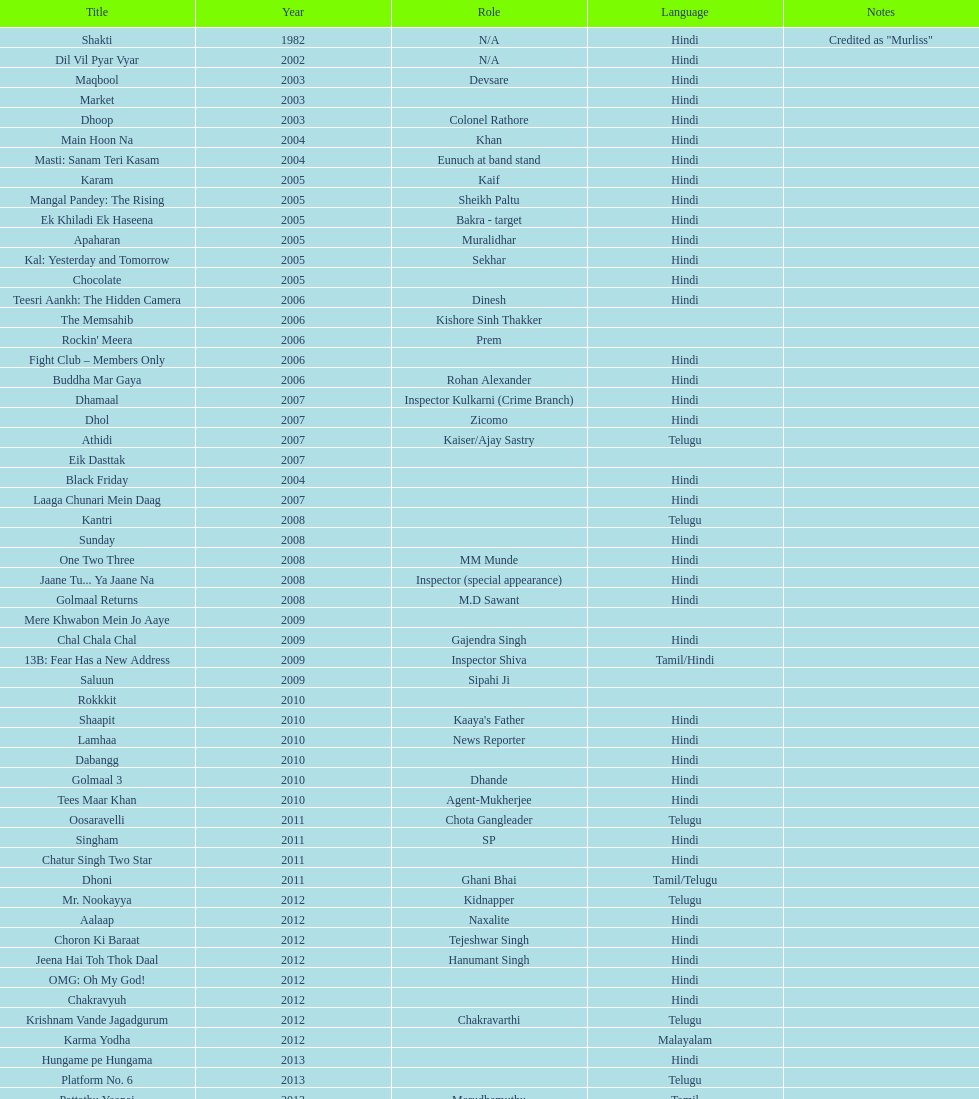Could you parse the entire table? {'header': ['Title', 'Year', 'Role', 'Language', 'Notes'], 'rows': [['Shakti', '1982', 'N/A', 'Hindi', 'Credited as "Murliss"'], ['Dil Vil Pyar Vyar', '2002', 'N/A', 'Hindi', ''], ['Maqbool', '2003', 'Devsare', 'Hindi', ''], ['Market', '2003', '', 'Hindi', ''], ['Dhoop', '2003', 'Colonel Rathore', 'Hindi', ''], ['Main Hoon Na', '2004', 'Khan', 'Hindi', ''], ['Masti: Sanam Teri Kasam', '2004', 'Eunuch at band stand', 'Hindi', ''], ['Karam', '2005', 'Kaif', 'Hindi', ''], ['Mangal Pandey: The Rising', '2005', 'Sheikh Paltu', 'Hindi', ''], ['Ek Khiladi Ek Haseena', '2005', 'Bakra - target', 'Hindi', ''], ['Apaharan', '2005', 'Muralidhar', 'Hindi', ''], ['Kal: Yesterday and Tomorrow', '2005', 'Sekhar', 'Hindi', ''], ['Chocolate', '2005', '', 'Hindi', ''], ['Teesri Aankh: The Hidden Camera', '2006', 'Dinesh', 'Hindi', ''], ['The Memsahib', '2006', 'Kishore Sinh Thakker', '', ''], ["Rockin' Meera", '2006', 'Prem', '', ''], ['Fight Club – Members Only', '2006', '', 'Hindi', ''], ['Buddha Mar Gaya', '2006', 'Rohan Alexander', 'Hindi', ''], ['Dhamaal', '2007', 'Inspector Kulkarni (Crime Branch)', 'Hindi', ''], ['Dhol', '2007', 'Zicomo', 'Hindi', ''], ['Athidi', '2007', 'Kaiser/Ajay Sastry', 'Telugu', ''], ['Eik Dasttak', '2007', '', '', ''], ['Black Friday', '2004', '', 'Hindi', ''], ['Laaga Chunari Mein Daag', '2007', '', 'Hindi', ''], ['Kantri', '2008', '', 'Telugu', ''], ['Sunday', '2008', '', 'Hindi', ''], ['One Two Three', '2008', 'MM Munde', 'Hindi', ''], ['Jaane Tu... Ya Jaane Na', '2008', 'Inspector (special appearance)', 'Hindi', ''], ['Golmaal Returns', '2008', 'M.D Sawant', 'Hindi', ''], ['Mere Khwabon Mein Jo Aaye', '2009', '', '', ''], ['Chal Chala Chal', '2009', 'Gajendra Singh', 'Hindi', ''], ['13B: Fear Has a New Address', '2009', 'Inspector Shiva', 'Tamil/Hindi', ''], ['Saluun', '2009', 'Sipahi Ji', '', ''], ['Rokkkit', '2010', '', '', ''], ['Shaapit', '2010', "Kaaya's Father", 'Hindi', ''], ['Lamhaa', '2010', 'News Reporter', 'Hindi', ''], ['Dabangg', '2010', '', 'Hindi', ''], ['Golmaal 3', '2010', 'Dhande', 'Hindi', ''], ['Tees Maar Khan', '2010', 'Agent-Mukherjee', 'Hindi', ''], ['Oosaravelli', '2011', 'Chota Gangleader', 'Telugu', ''], ['Singham', '2011', 'SP', 'Hindi', ''], ['Chatur Singh Two Star', '2011', '', 'Hindi', ''], ['Dhoni', '2011', 'Ghani Bhai', 'Tamil/Telugu', ''], ['Mr. Nookayya', '2012', 'Kidnapper', 'Telugu', ''], ['Aalaap', '2012', 'Naxalite', 'Hindi', ''], ['Choron Ki Baraat', '2012', 'Tejeshwar Singh', 'Hindi', ''], ['Jeena Hai Toh Thok Daal', '2012', 'Hanumant Singh', 'Hindi', ''], ['OMG: Oh My God!', '2012', '', 'Hindi', ''], ['Chakravyuh', '2012', '', 'Hindi', ''], ['Krishnam Vande Jagadgurum', '2012', 'Chakravarthi', 'Telugu', ''], ['Karma Yodha', '2012', '', 'Malayalam', ''], ['Hungame pe Hungama', '2013', '', 'Hindi', ''], ['Platform No. 6', '2013', '', 'Telugu', ''], ['Pattathu Yaanai', '2013', 'Marudhamuthu', 'Tamil', ''], ['Zindagi 50-50', '2013', '', 'Hindi', ''], ['Yevadu', '2013', 'Durani', 'Telugu', ''], ['Karmachari', '2013', '', 'Telugu', '']]} What was the last malayalam film this actor starred in? Karma Yodha. 